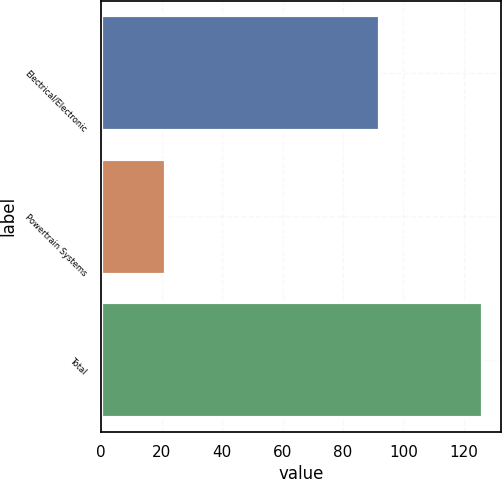Convert chart to OTSL. <chart><loc_0><loc_0><loc_500><loc_500><bar_chart><fcel>Electrical/Electronic<fcel>Powertrain Systems<fcel>Total<nl><fcel>92<fcel>21<fcel>126<nl></chart> 